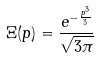<formula> <loc_0><loc_0><loc_500><loc_500>\Xi ( p ) = \frac { e ^ { - \frac { p ^ { 3 } } { 3 } } } { \sqrt { 3 \pi } }</formula> 